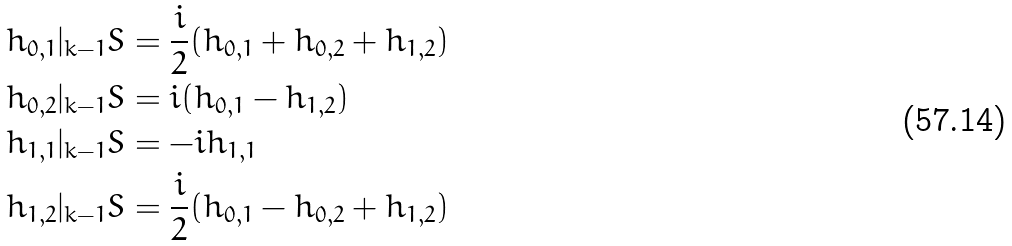<formula> <loc_0><loc_0><loc_500><loc_500>& h _ { 0 , 1 } | _ { k - 1 } S = \frac { i } { 2 } ( h _ { 0 , 1 } + h _ { 0 , 2 } + h _ { 1 , 2 } ) \\ & h _ { 0 , 2 } | _ { k - 1 } S = i ( h _ { 0 , 1 } - h _ { 1 , 2 } ) \\ & h _ { 1 , 1 } | _ { k - 1 } S = - i h _ { 1 , 1 } \\ & h _ { 1 , 2 } | _ { k - 1 } S = \frac { i } { 2 } ( h _ { 0 , 1 } - h _ { 0 , 2 } + h _ { 1 , 2 } )</formula> 